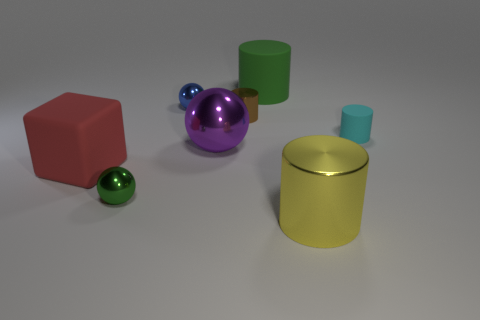Subtract 1 cylinders. How many cylinders are left? 3 Add 1 purple balls. How many objects exist? 9 Subtract all balls. How many objects are left? 5 Add 6 large purple metallic objects. How many large purple metallic objects are left? 7 Add 7 red cubes. How many red cubes exist? 8 Subtract 0 purple cubes. How many objects are left? 8 Subtract all large yellow metal cylinders. Subtract all red objects. How many objects are left? 6 